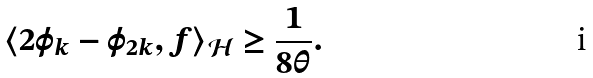<formula> <loc_0><loc_0><loc_500><loc_500>\langle 2 \varphi _ { k } - \varphi _ { 2 k } , f \rangle _ { \mathcal { H } } \geq \frac { 1 } { 8 \theta } .</formula> 